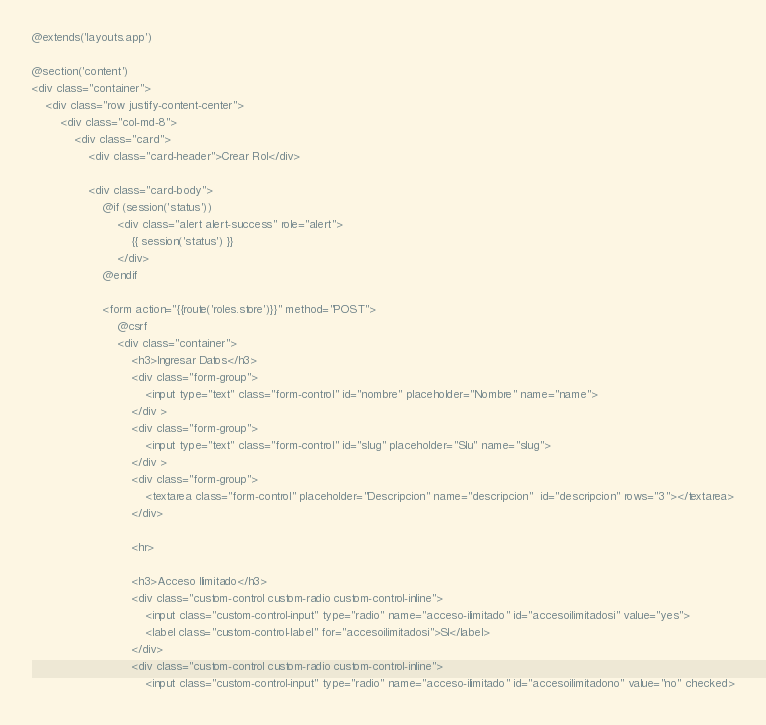<code> <loc_0><loc_0><loc_500><loc_500><_PHP_>@extends('layouts.app')

@section('content')
<div class="container">
    <div class="row justify-content-center">
        <div class="col-md-8">
            <div class="card">
                <div class="card-header">Crear Rol</div>

                <div class="card-body">
                    @if (session('status'))
                        <div class="alert alert-success" role="alert">
                            {{ session('status') }}
                        </div>
                    @endif

                    <form action="{{route('roles.store')}}" method="POST">
                        @csrf
                        <div class="container">
                            <h3>Ingresar Datos</h3>
                            <div class="form-group">
                                <input type="text" class="form-control" id="nombre" placeholder="Nombre" name="name">
                            </div >
                            <div class="form-group">
                                <input type="text" class="form-control" id="slug" placeholder="Slu" name="slug">
                            </div >
                            <div class="form-group">
                                <textarea class="form-control" placeholder="Descripcion" name="descripcion"  id="descripcion" rows="3"></textarea>
                            </div>

                            <hr>

                            <h3>Acceso Ilimitado</h3>
                            <div class="custom-control custom-radio custom-control-inline">
                                <input class="custom-control-input" type="radio" name="acceso-ilimitado" id="accesoilimitadosi" value="yes">
                                <label class="custom-control-label" for="accesoilimitadosi">SI</label>
                            </div>
                            <div class="custom-control custom-radio custom-control-inline">
                                <input class="custom-control-input" type="radio" name="acceso-ilimitado" id="accesoilimitadono" value="no" checked></code> 